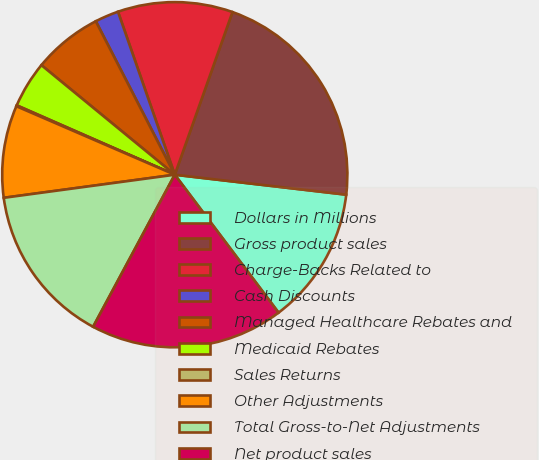Convert chart to OTSL. <chart><loc_0><loc_0><loc_500><loc_500><pie_chart><fcel>Dollars in Millions<fcel>Gross product sales<fcel>Charge-Backs Related to<fcel>Cash Discounts<fcel>Managed Healthcare Rebates and<fcel>Medicaid Rebates<fcel>Sales Returns<fcel>Other Adjustments<fcel>Total Gross-to-Net Adjustments<fcel>Net product sales<nl><fcel>12.89%<fcel>21.42%<fcel>10.76%<fcel>2.23%<fcel>6.49%<fcel>4.36%<fcel>0.09%<fcel>8.63%<fcel>15.02%<fcel>18.11%<nl></chart> 